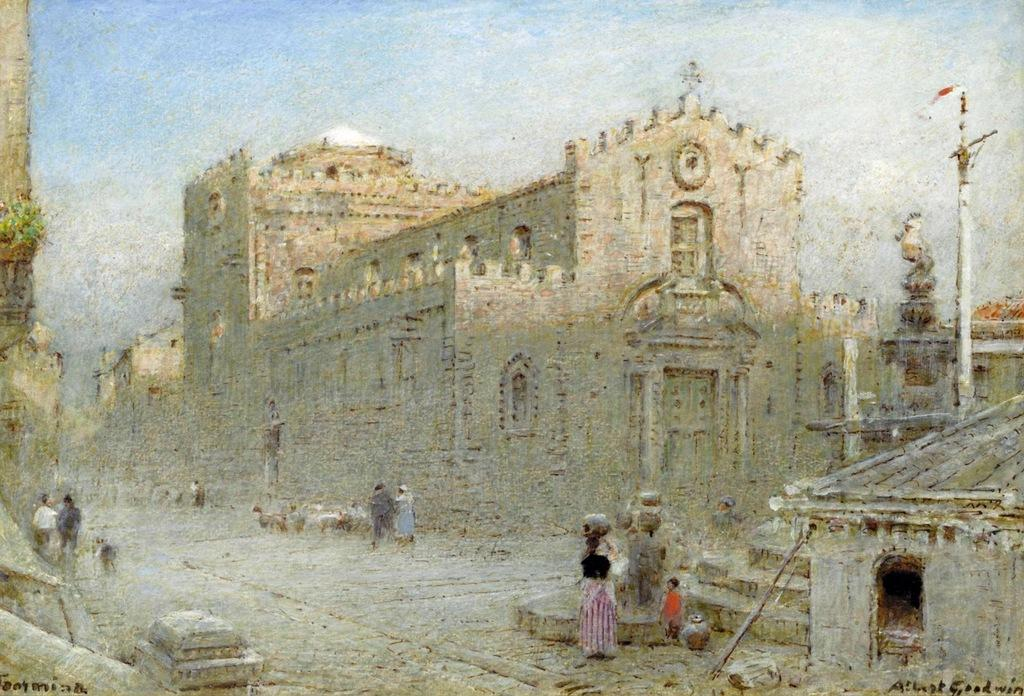What is the main subject of the image? There is a picture of a building in the image. What else can be seen in the image besides the building? There are people standing on a pathway and poles visible in the image. What is the condition of the sky in the image? The sky appears to be cloudy in the image. What type of cherry flavor can be tasted in the image? There is no cherry flavor present in the image, as it is a picture of a building and people on a pathway. What type of skin condition can be seen on the people in the image? There is no indication of any skin conditions on the people in the image; they appear to be standing on a pathway. 